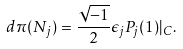<formula> <loc_0><loc_0><loc_500><loc_500>d \pi ( N _ { j } ) = \frac { \sqrt { - 1 } } { 2 } \epsilon _ { j } P _ { j } ( 1 ) | _ { C } .</formula> 